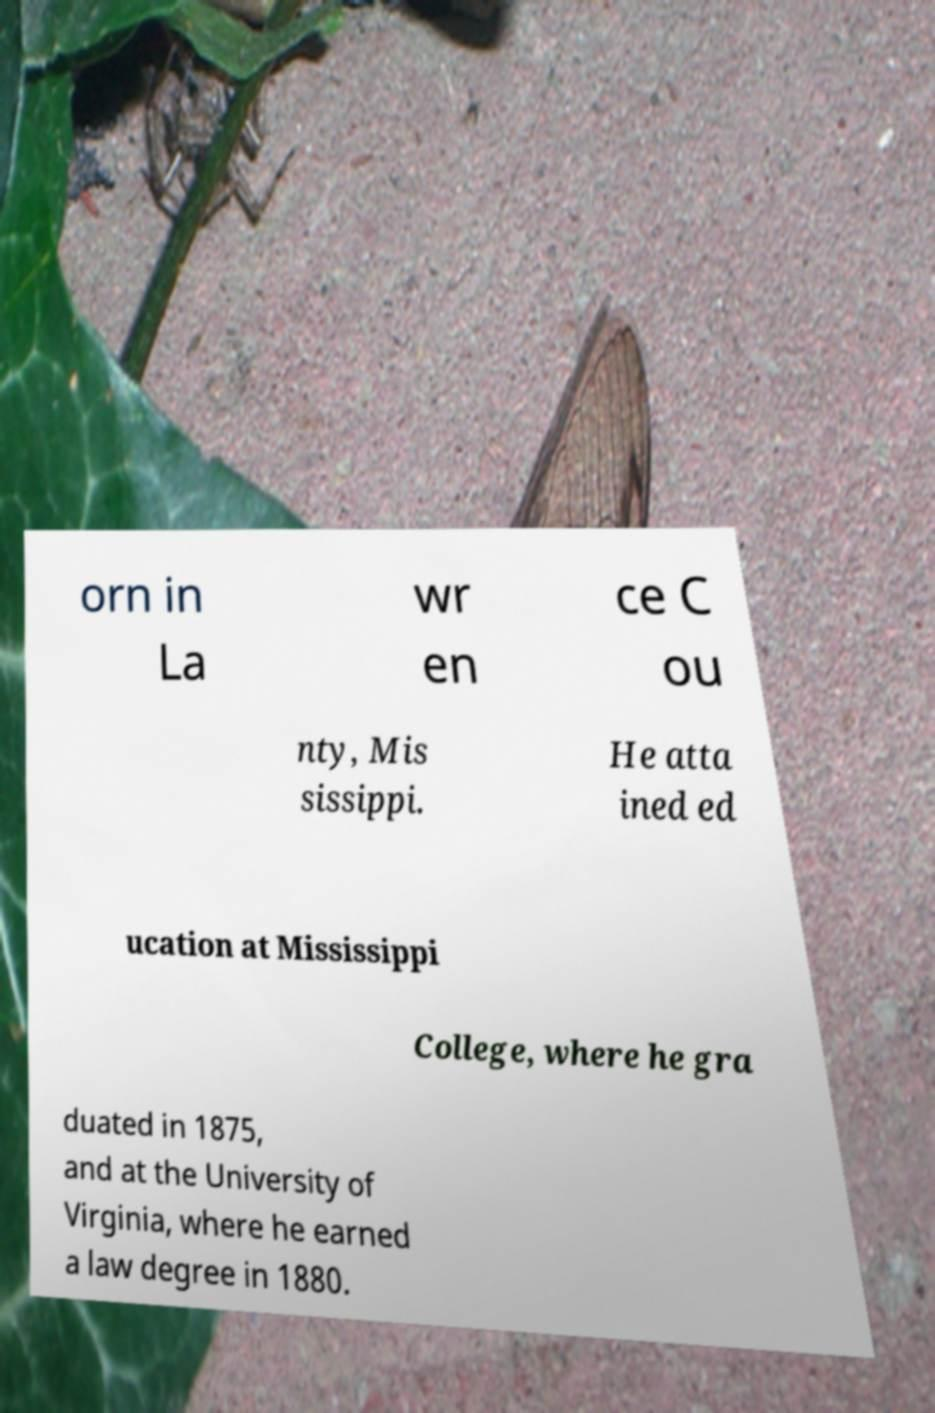There's text embedded in this image that I need extracted. Can you transcribe it verbatim? orn in La wr en ce C ou nty, Mis sissippi. He atta ined ed ucation at Mississippi College, where he gra duated in 1875, and at the University of Virginia, where he earned a law degree in 1880. 